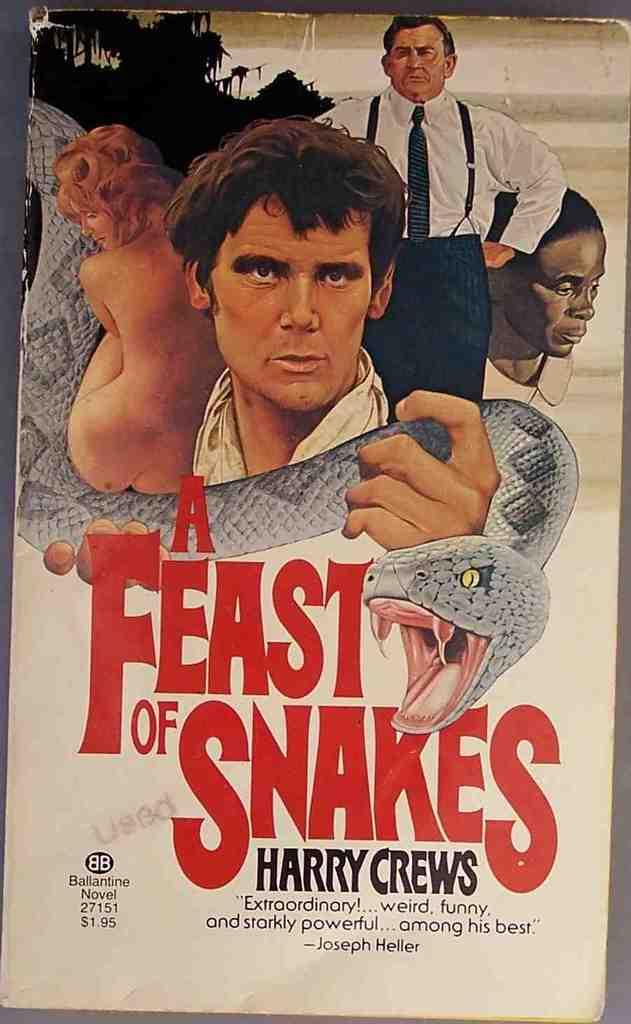Provide a one-sentence caption for the provided image. Harry Crews stars in a book titled A Feat of Snakes that features three men and a naked woman on the cover. 